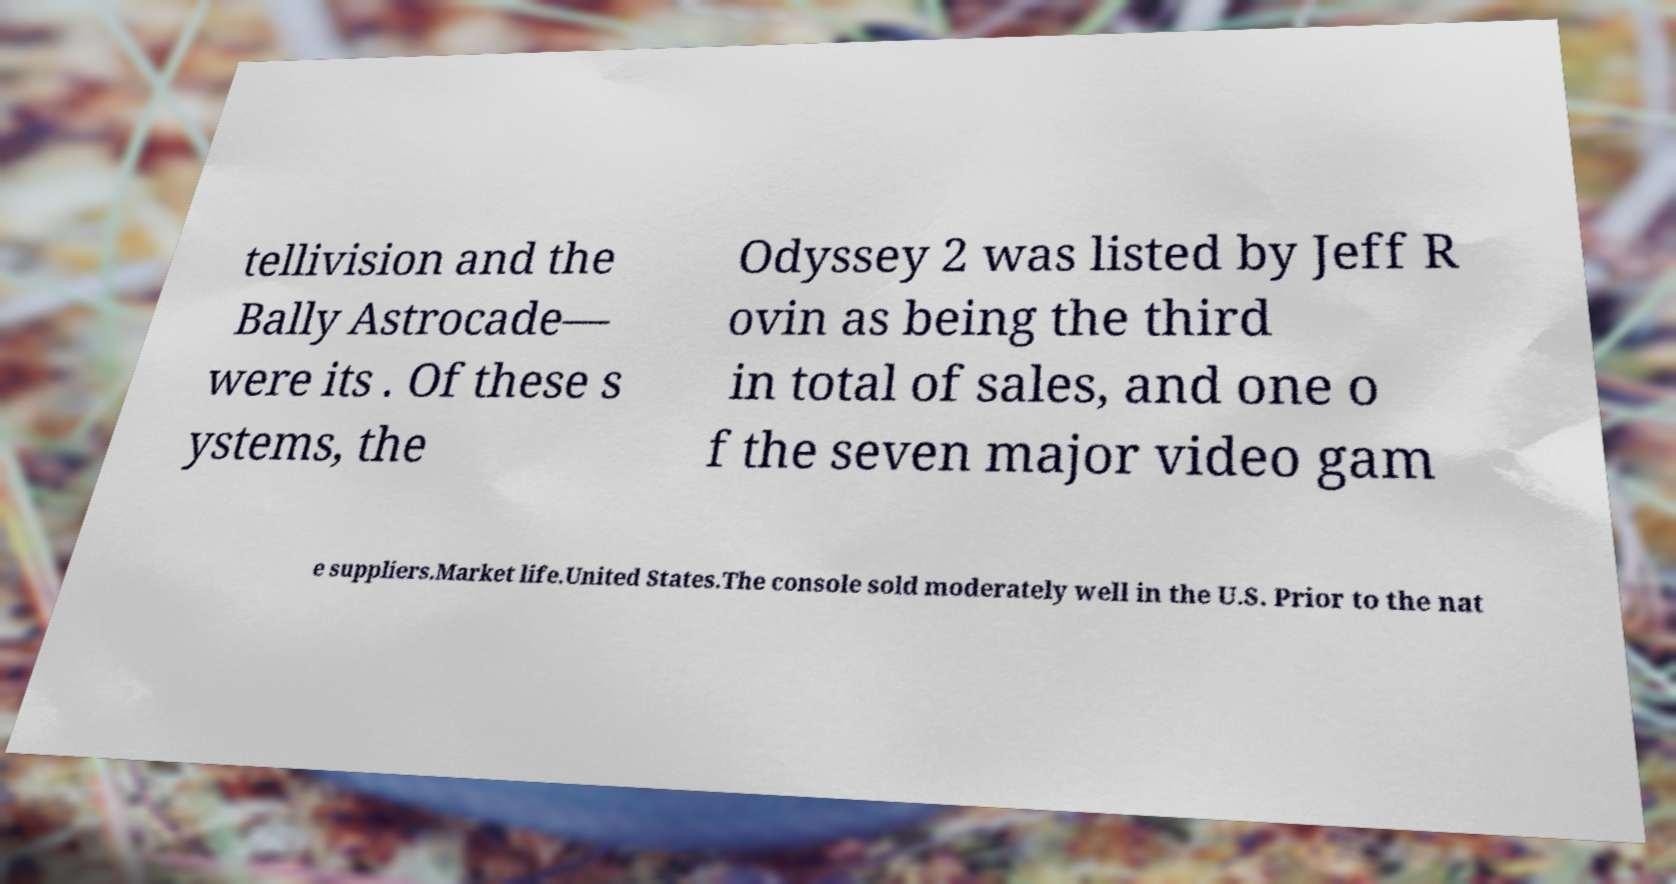Could you extract and type out the text from this image? tellivision and the Bally Astrocade— were its . Of these s ystems, the Odyssey 2 was listed by Jeff R ovin as being the third in total of sales, and one o f the seven major video gam e suppliers.Market life.United States.The console sold moderately well in the U.S. Prior to the nat 